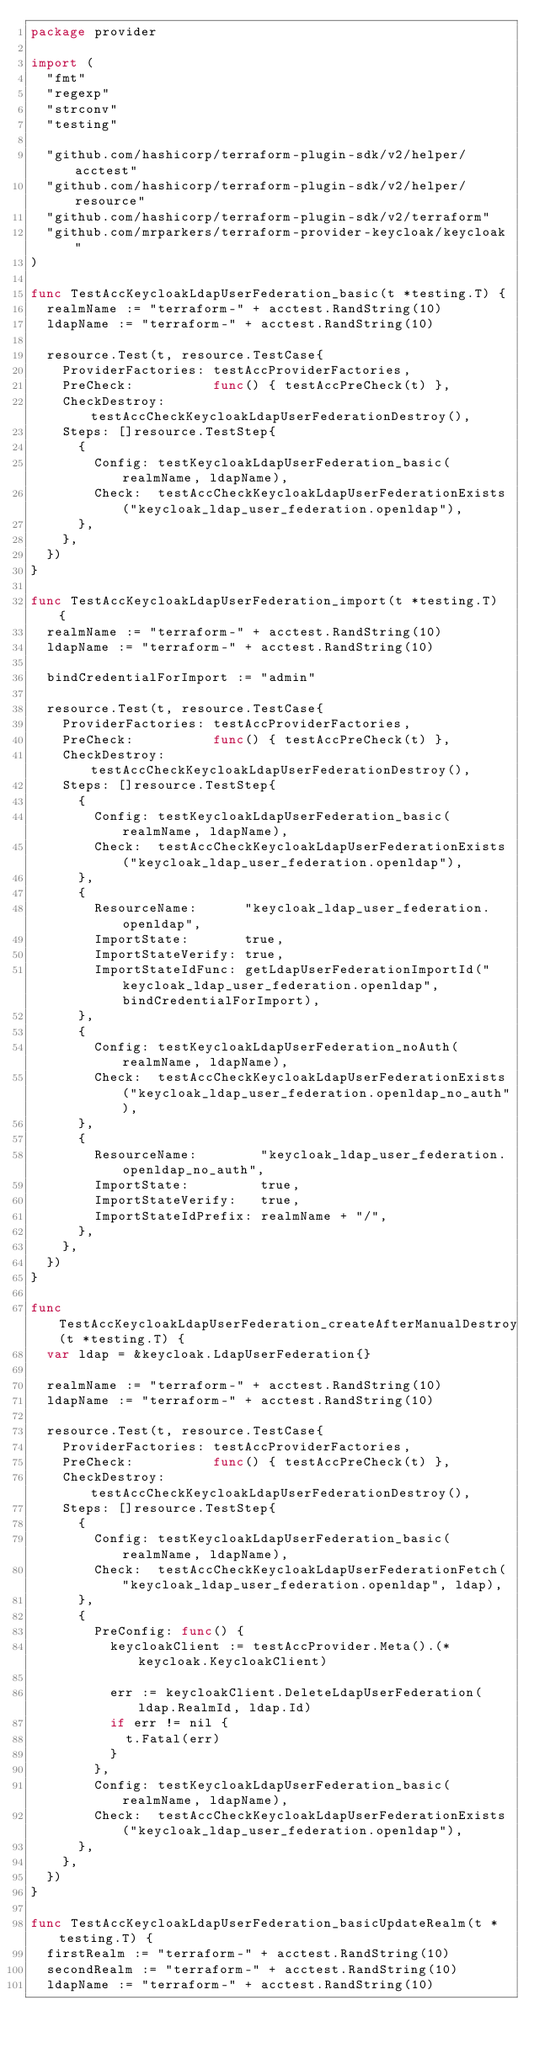<code> <loc_0><loc_0><loc_500><loc_500><_Go_>package provider

import (
	"fmt"
	"regexp"
	"strconv"
	"testing"

	"github.com/hashicorp/terraform-plugin-sdk/v2/helper/acctest"
	"github.com/hashicorp/terraform-plugin-sdk/v2/helper/resource"
	"github.com/hashicorp/terraform-plugin-sdk/v2/terraform"
	"github.com/mrparkers/terraform-provider-keycloak/keycloak"
)

func TestAccKeycloakLdapUserFederation_basic(t *testing.T) {
	realmName := "terraform-" + acctest.RandString(10)
	ldapName := "terraform-" + acctest.RandString(10)

	resource.Test(t, resource.TestCase{
		ProviderFactories: testAccProviderFactories,
		PreCheck:          func() { testAccPreCheck(t) },
		CheckDestroy:      testAccCheckKeycloakLdapUserFederationDestroy(),
		Steps: []resource.TestStep{
			{
				Config: testKeycloakLdapUserFederation_basic(realmName, ldapName),
				Check:  testAccCheckKeycloakLdapUserFederationExists("keycloak_ldap_user_federation.openldap"),
			},
		},
	})
}

func TestAccKeycloakLdapUserFederation_import(t *testing.T) {
	realmName := "terraform-" + acctest.RandString(10)
	ldapName := "terraform-" + acctest.RandString(10)

	bindCredentialForImport := "admin"

	resource.Test(t, resource.TestCase{
		ProviderFactories: testAccProviderFactories,
		PreCheck:          func() { testAccPreCheck(t) },
		CheckDestroy:      testAccCheckKeycloakLdapUserFederationDestroy(),
		Steps: []resource.TestStep{
			{
				Config: testKeycloakLdapUserFederation_basic(realmName, ldapName),
				Check:  testAccCheckKeycloakLdapUserFederationExists("keycloak_ldap_user_federation.openldap"),
			},
			{
				ResourceName:      "keycloak_ldap_user_federation.openldap",
				ImportState:       true,
				ImportStateVerify: true,
				ImportStateIdFunc: getLdapUserFederationImportId("keycloak_ldap_user_federation.openldap", bindCredentialForImport),
			},
			{
				Config: testKeycloakLdapUserFederation_noAuth(realmName, ldapName),
				Check:  testAccCheckKeycloakLdapUserFederationExists("keycloak_ldap_user_federation.openldap_no_auth"),
			},
			{
				ResourceName:        "keycloak_ldap_user_federation.openldap_no_auth",
				ImportState:         true,
				ImportStateVerify:   true,
				ImportStateIdPrefix: realmName + "/",
			},
		},
	})
}

func TestAccKeycloakLdapUserFederation_createAfterManualDestroy(t *testing.T) {
	var ldap = &keycloak.LdapUserFederation{}

	realmName := "terraform-" + acctest.RandString(10)
	ldapName := "terraform-" + acctest.RandString(10)

	resource.Test(t, resource.TestCase{
		ProviderFactories: testAccProviderFactories,
		PreCheck:          func() { testAccPreCheck(t) },
		CheckDestroy:      testAccCheckKeycloakLdapUserFederationDestroy(),
		Steps: []resource.TestStep{
			{
				Config: testKeycloakLdapUserFederation_basic(realmName, ldapName),
				Check:  testAccCheckKeycloakLdapUserFederationFetch("keycloak_ldap_user_federation.openldap", ldap),
			},
			{
				PreConfig: func() {
					keycloakClient := testAccProvider.Meta().(*keycloak.KeycloakClient)

					err := keycloakClient.DeleteLdapUserFederation(ldap.RealmId, ldap.Id)
					if err != nil {
						t.Fatal(err)
					}
				},
				Config: testKeycloakLdapUserFederation_basic(realmName, ldapName),
				Check:  testAccCheckKeycloakLdapUserFederationExists("keycloak_ldap_user_federation.openldap"),
			},
		},
	})
}

func TestAccKeycloakLdapUserFederation_basicUpdateRealm(t *testing.T) {
	firstRealm := "terraform-" + acctest.RandString(10)
	secondRealm := "terraform-" + acctest.RandString(10)
	ldapName := "terraform-" + acctest.RandString(10)
</code> 